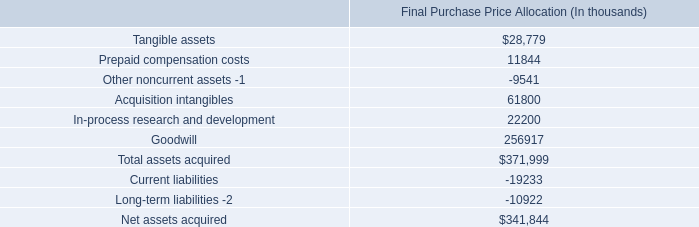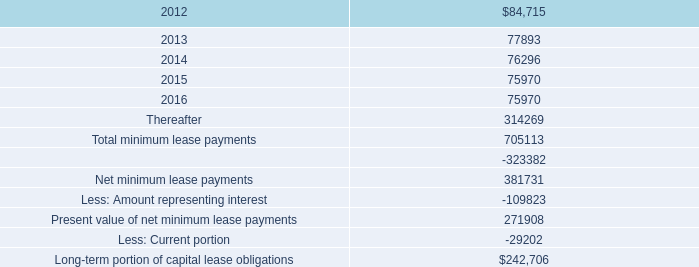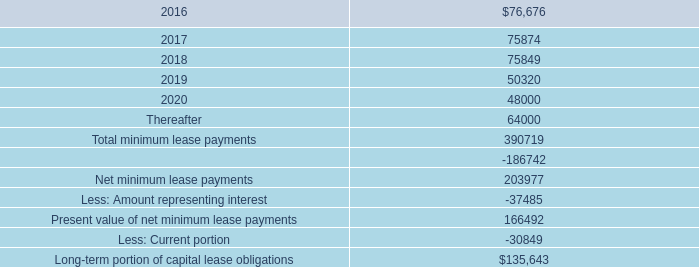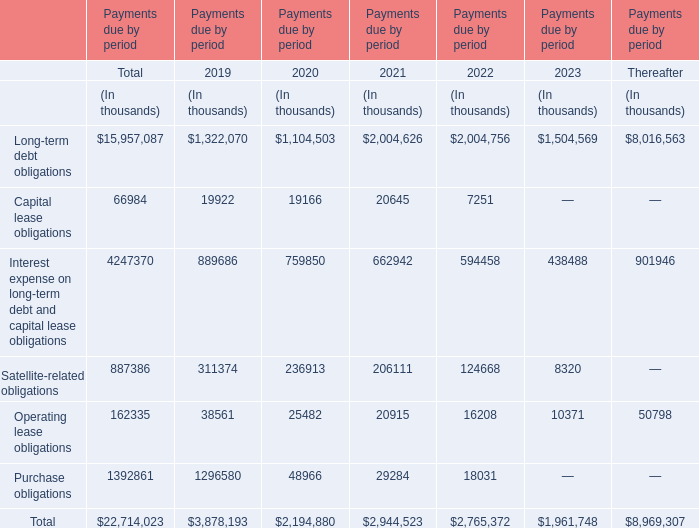What do all Payments due by period sum up without those Payments due by period smaller than 900000, in 2019? (in thousand) 
Computations: (1322070 + 1296580)
Answer: 2618650.0. 